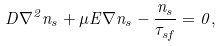Convert formula to latex. <formula><loc_0><loc_0><loc_500><loc_500>D \nabla ^ { 2 } n _ { s } + \mu E \nabla n _ { s } - \frac { n _ { s } } { \tau _ { s f } } = 0 ,</formula> 